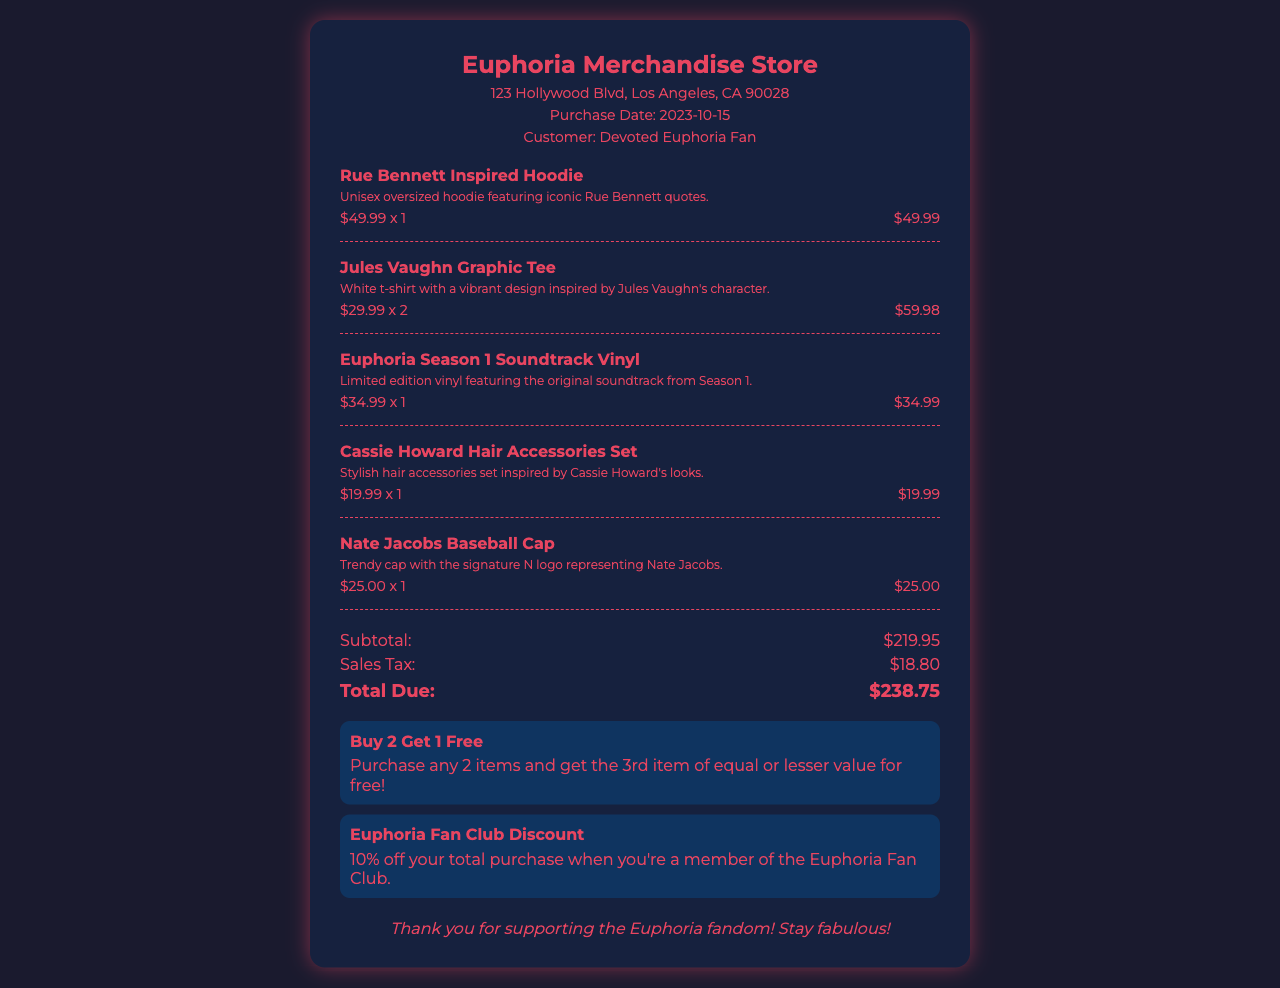What is the purchase date? The purchase date is stated clearly in the document under "Purchase Date".
Answer: 2023-10-15 How many Jules Vaughn Graphic Tees were purchased? The number of purchased Jules Vaughn Graphic Tees is mentioned in the "item details" for that item.
Answer: 2 What is the total due amount? The total due amount is calculated and displayed at the bottom of the document under "Total Due".
Answer: $238.75 What is the price of the Rue Bennett Inspired Hoodie? The price for the Rue Bennett Inspired Hoodie is specified in the "item details".
Answer: $49.99 What promotion offers a discount for fan club members? The specific promotion for fan club members is listed under "promotions" in the document.
Answer: Euphoria Fan Club Discount What is the subtotal of the purchase? The subtotal is indicated in the "totals" section of the receipt.
Answer: $219.95 How many hair accessories are included in the Cassie Howard set? The number of items included in the Cassie Howard Hair Accessories Set is not explicitly stated but it is referred to as a set.
Answer: Set What is the address of the merchandise store? The address is provided in the header section of the document.
Answer: 123 Hollywood Blvd, Los Angeles, CA 90028 What is the item description for the Nate Jacobs Baseball Cap? The description for the Nate Jacobs Baseball Cap is given right below the item name in the item section.
Answer: Trendy cap with the signature N logo representing Nate Jacobs 